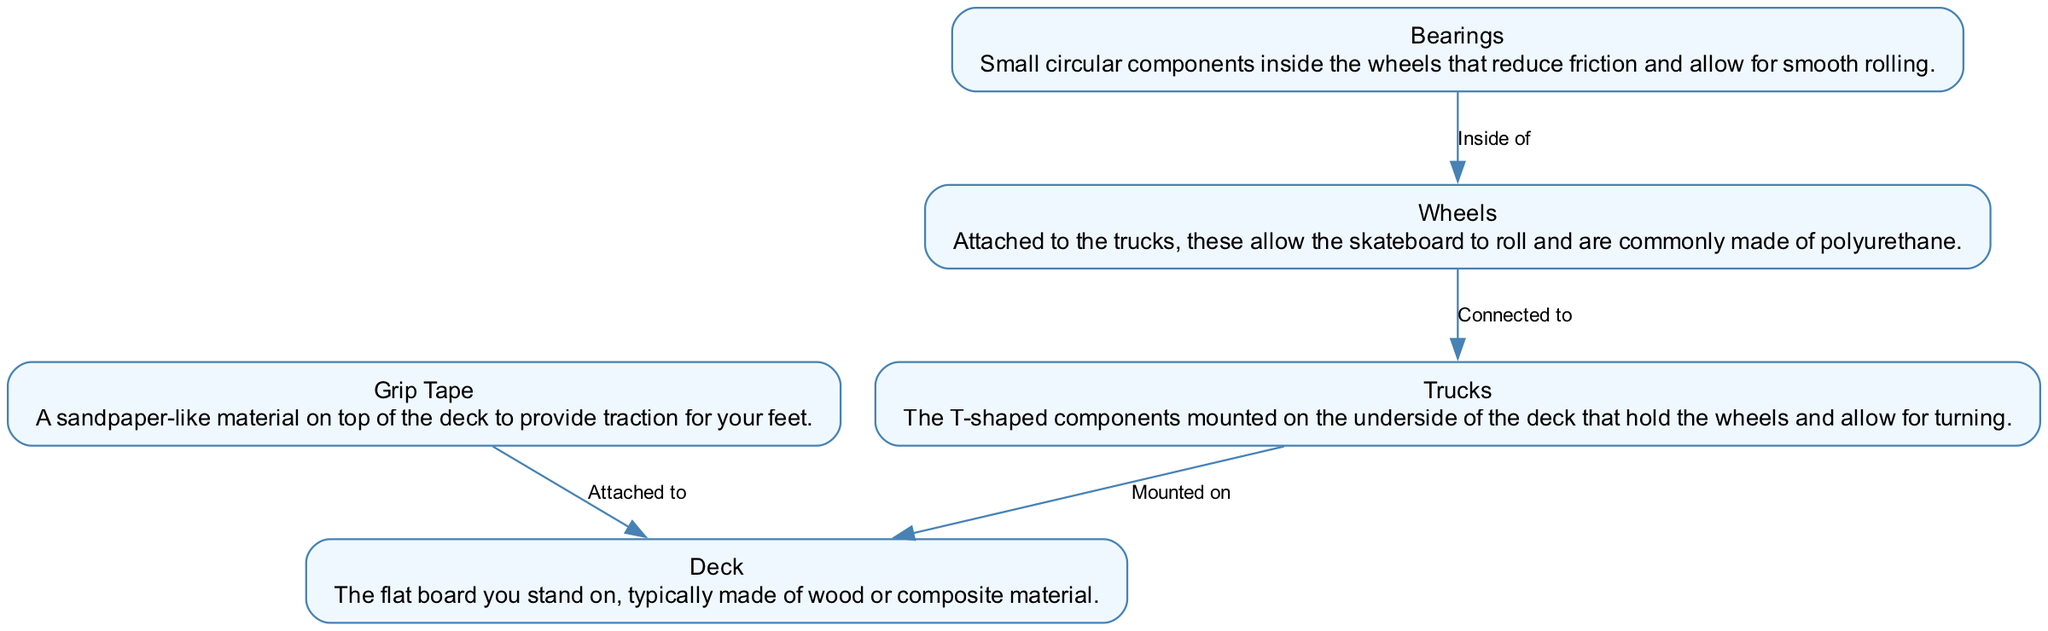What's the main component you stand on? The diagram identifies the main component you stand on as the "Deck," which is described as the flat board typically made of wood or composite material.
Answer: Deck What attaches to the deck for traction? According to the diagram, the component that attaches to the deck for traction is the "Grip Tape," a sandpaper-like material placed on top of the deck.
Answer: Grip Tape How many components are listed in the diagram? The diagram lists five components: deck, grip tape, trucks, wheels, and bearings. Counting these components gives the total number.
Answer: Five Which component allows for turning? The "Trucks" are identified in the diagram as the component that allows for turning on the skateboard, as they are mounted on the underside of the deck and hold the wheels.
Answer: Trucks Where are the bearings located? The diagram states that the "Bearings" are located inside the wheels, which is indicated by the direct connection between these two components.
Answer: Inside the wheels What is the relationship between the trucks and the deck? The relationship is established in the diagram where it shows that the trucks are "Mounted on" the deck, highlighting their connection to this main component.
Answer: Mounted on What material are the wheels commonly made of? The diagram specifies that the wheels are commonly made of "polyurethane," which describes their material composition.
Answer: Polyurethane Which component connects directly to the wheels? The diagram shows that the "Trucks" are the component that connects directly to the wheels, emphasizing their role in the skateboard's structure.
Answer: Trucks What is the purpose of the bearings? The diagram describes that the purpose of the bearings is to "reduce friction and allow for smooth rolling," indicating their functional importance within the wheels.
Answer: Reduce friction and allow for smooth rolling 